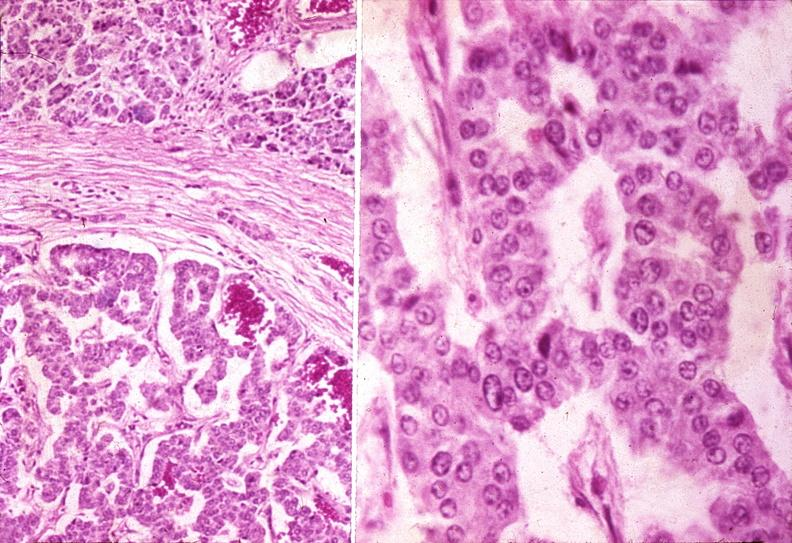does this image show islet cell carcinoma?
Answer the question using a single word or phrase. Yes 